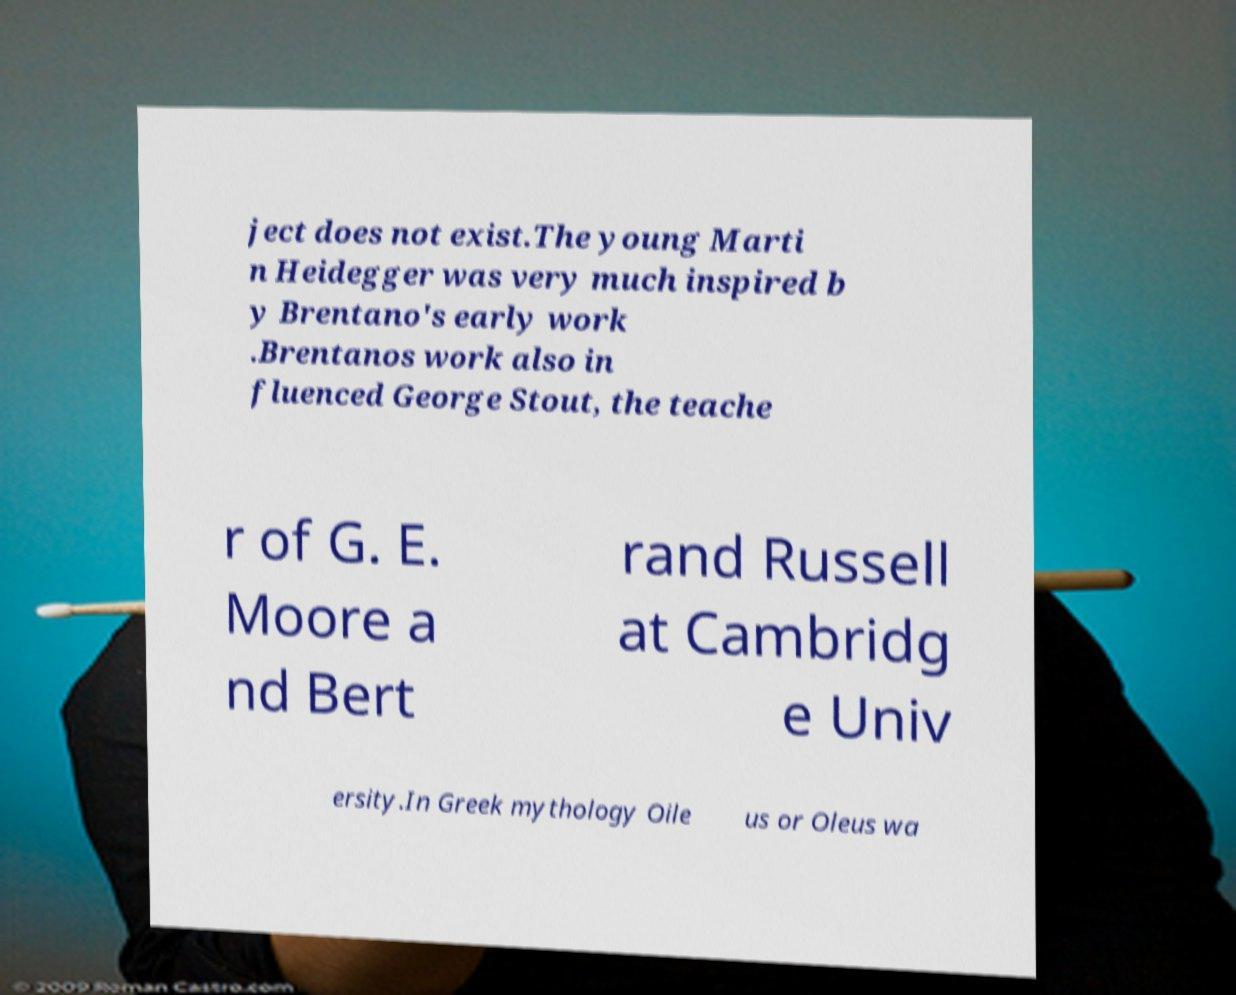Please read and relay the text visible in this image. What does it say? ject does not exist.The young Marti n Heidegger was very much inspired b y Brentano's early work .Brentanos work also in fluenced George Stout, the teache r of G. E. Moore a nd Bert rand Russell at Cambridg e Univ ersity.In Greek mythology Oile us or Oleus wa 